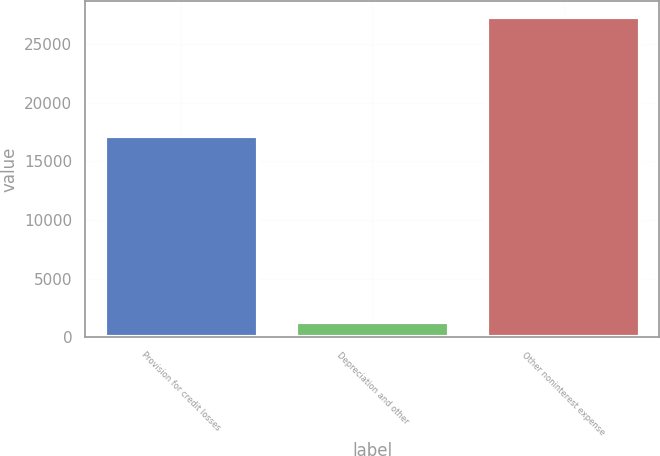<chart> <loc_0><loc_0><loc_500><loc_500><bar_chart><fcel>Provision for credit losses<fcel>Depreciation and other<fcel>Other noninterest expense<nl><fcel>17129<fcel>1330<fcel>27313<nl></chart> 